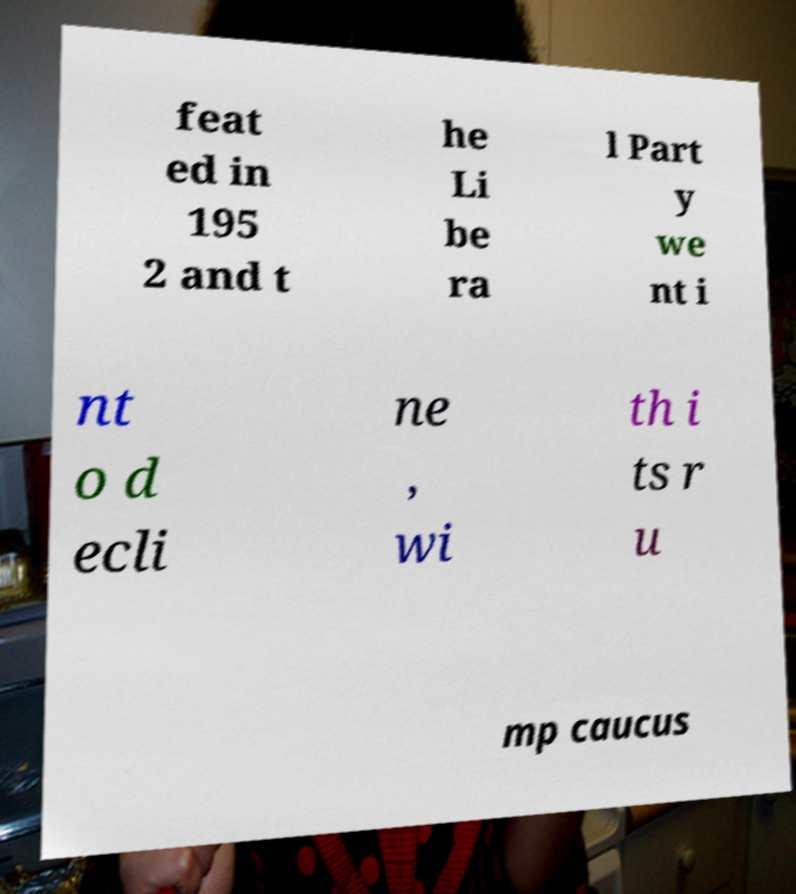Please identify and transcribe the text found in this image. feat ed in 195 2 and t he Li be ra l Part y we nt i nt o d ecli ne , wi th i ts r u mp caucus 